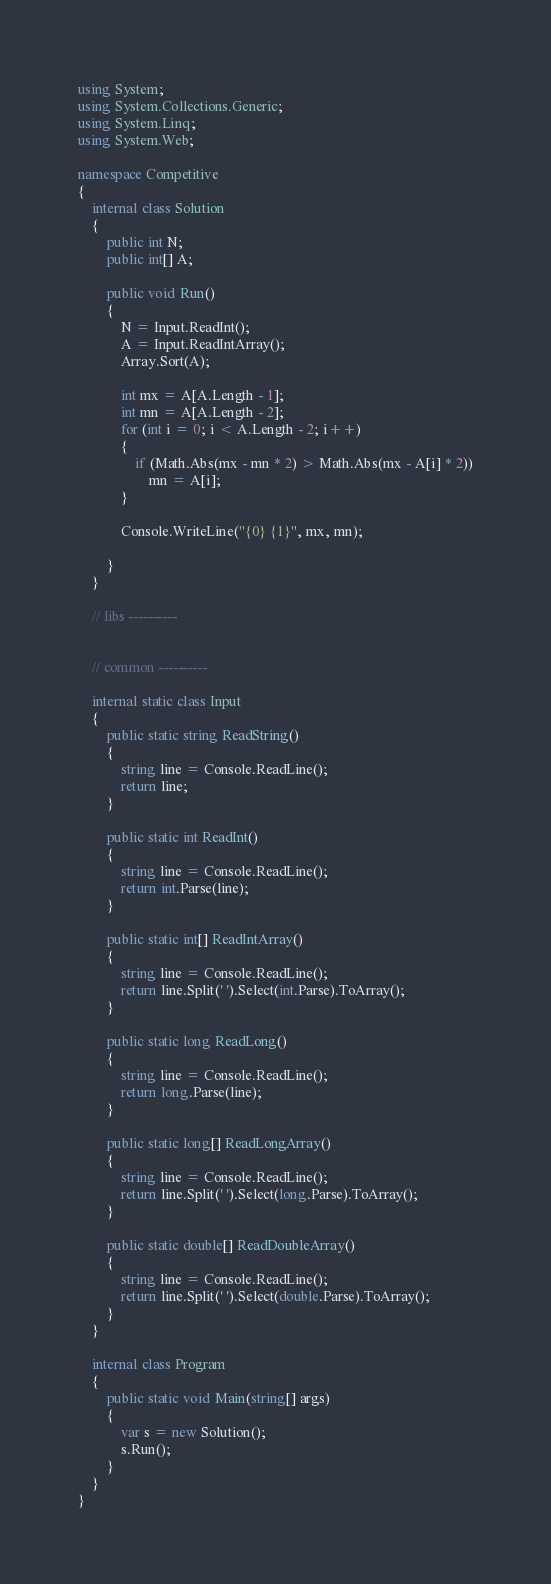Convert code to text. <code><loc_0><loc_0><loc_500><loc_500><_C#_>using System;
using System.Collections.Generic;
using System.Linq;
using System.Web;

namespace Competitive
{
    internal class Solution
    {
        public int N;
        public int[] A;

        public void Run()
        {
            N = Input.ReadInt();
            A = Input.ReadIntArray();
            Array.Sort(A);

            int mx = A[A.Length - 1];
            int mn = A[A.Length - 2];
            for (int i = 0; i < A.Length - 2; i++)
            {
                if (Math.Abs(mx - mn * 2) > Math.Abs(mx - A[i] * 2))
                    mn = A[i];
            }

            Console.WriteLine("{0} {1}", mx, mn);

        }
    }

    // libs ----------


    // common ----------

    internal static class Input
    {
        public static string ReadString()
        {
            string line = Console.ReadLine();
            return line;
        }

        public static int ReadInt()
        {
            string line = Console.ReadLine();
            return int.Parse(line);
        }

        public static int[] ReadIntArray()
        {
            string line = Console.ReadLine();
            return line.Split(' ').Select(int.Parse).ToArray();
        }

        public static long ReadLong()
        {
            string line = Console.ReadLine();
            return long.Parse(line);
        }

        public static long[] ReadLongArray()
        {
            string line = Console.ReadLine();
            return line.Split(' ').Select(long.Parse).ToArray();
        }

        public static double[] ReadDoubleArray()
        {
            string line = Console.ReadLine();
            return line.Split(' ').Select(double.Parse).ToArray();
        }
    }

    internal class Program
    {
        public static void Main(string[] args)
        {
            var s = new Solution();
            s.Run();
        }
    }
}</code> 